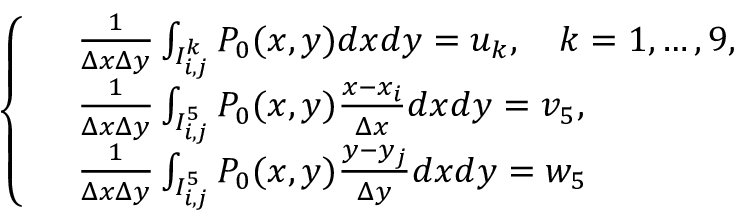<formula> <loc_0><loc_0><loc_500><loc_500>\begin{array} { r } { \left \{ \begin{array} { r l } & { \frac { 1 } { \Delta x \Delta y } \int _ { I _ { i , j } ^ { k } } P _ { 0 } ( x , y ) d x d y = u _ { k } , \quad k = 1 , \dots , 9 , } \\ & { \frac { 1 } { \Delta x \Delta y } \int _ { I _ { i , j } ^ { 5 } } P _ { 0 } ( x , y ) \frac { x - x _ { i } } { \Delta x } d x d y = v _ { 5 } , } \\ & { \frac { 1 } { \Delta x \Delta y } \int _ { I _ { i , j } ^ { 5 } } P _ { 0 } ( x , y ) \frac { y - y _ { j } } { \Delta y } d x d y = w _ { 5 } } \end{array} } \end{array}</formula> 